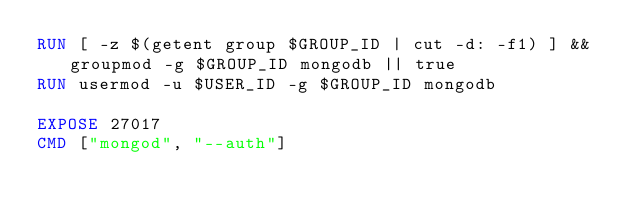<code> <loc_0><loc_0><loc_500><loc_500><_Dockerfile_>RUN [ -z $(getent group $GROUP_ID | cut -d: -f1) ] && groupmod -g $GROUP_ID mongodb || true
RUN usermod -u $USER_ID -g $GROUP_ID mongodb

EXPOSE 27017
CMD ["mongod", "--auth"]
</code> 